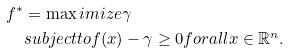Convert formula to latex. <formula><loc_0><loc_0><loc_500><loc_500>f ^ { * } & = \max i m i z e \gamma \\ & s u b j e c t t o f ( x ) - \gamma \geq 0 f o r a l l x \in \mathbb { R } ^ { n } .</formula> 